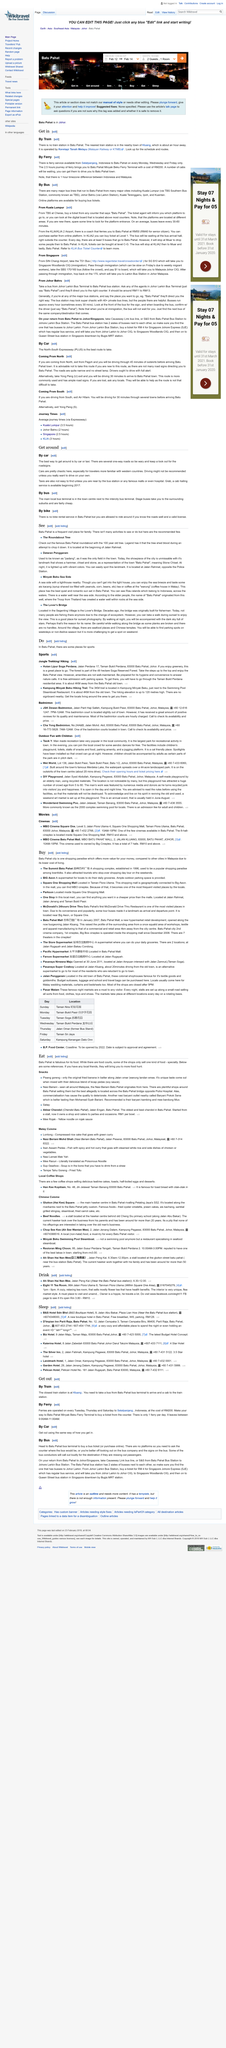Draw attention to some important aspects in this diagram. Several major bus lines operate routes to Batu Pahat from various major cities, including TBS Southern Bus Station and Larkin Station. Only on Mondays, Wednesdays, and Fridays can one reach Batu Pahat Selatpanjang, Indonesia. Indonesia and Malaysia are in different time zones, resulting in a 1 hour time difference between the two countries. 